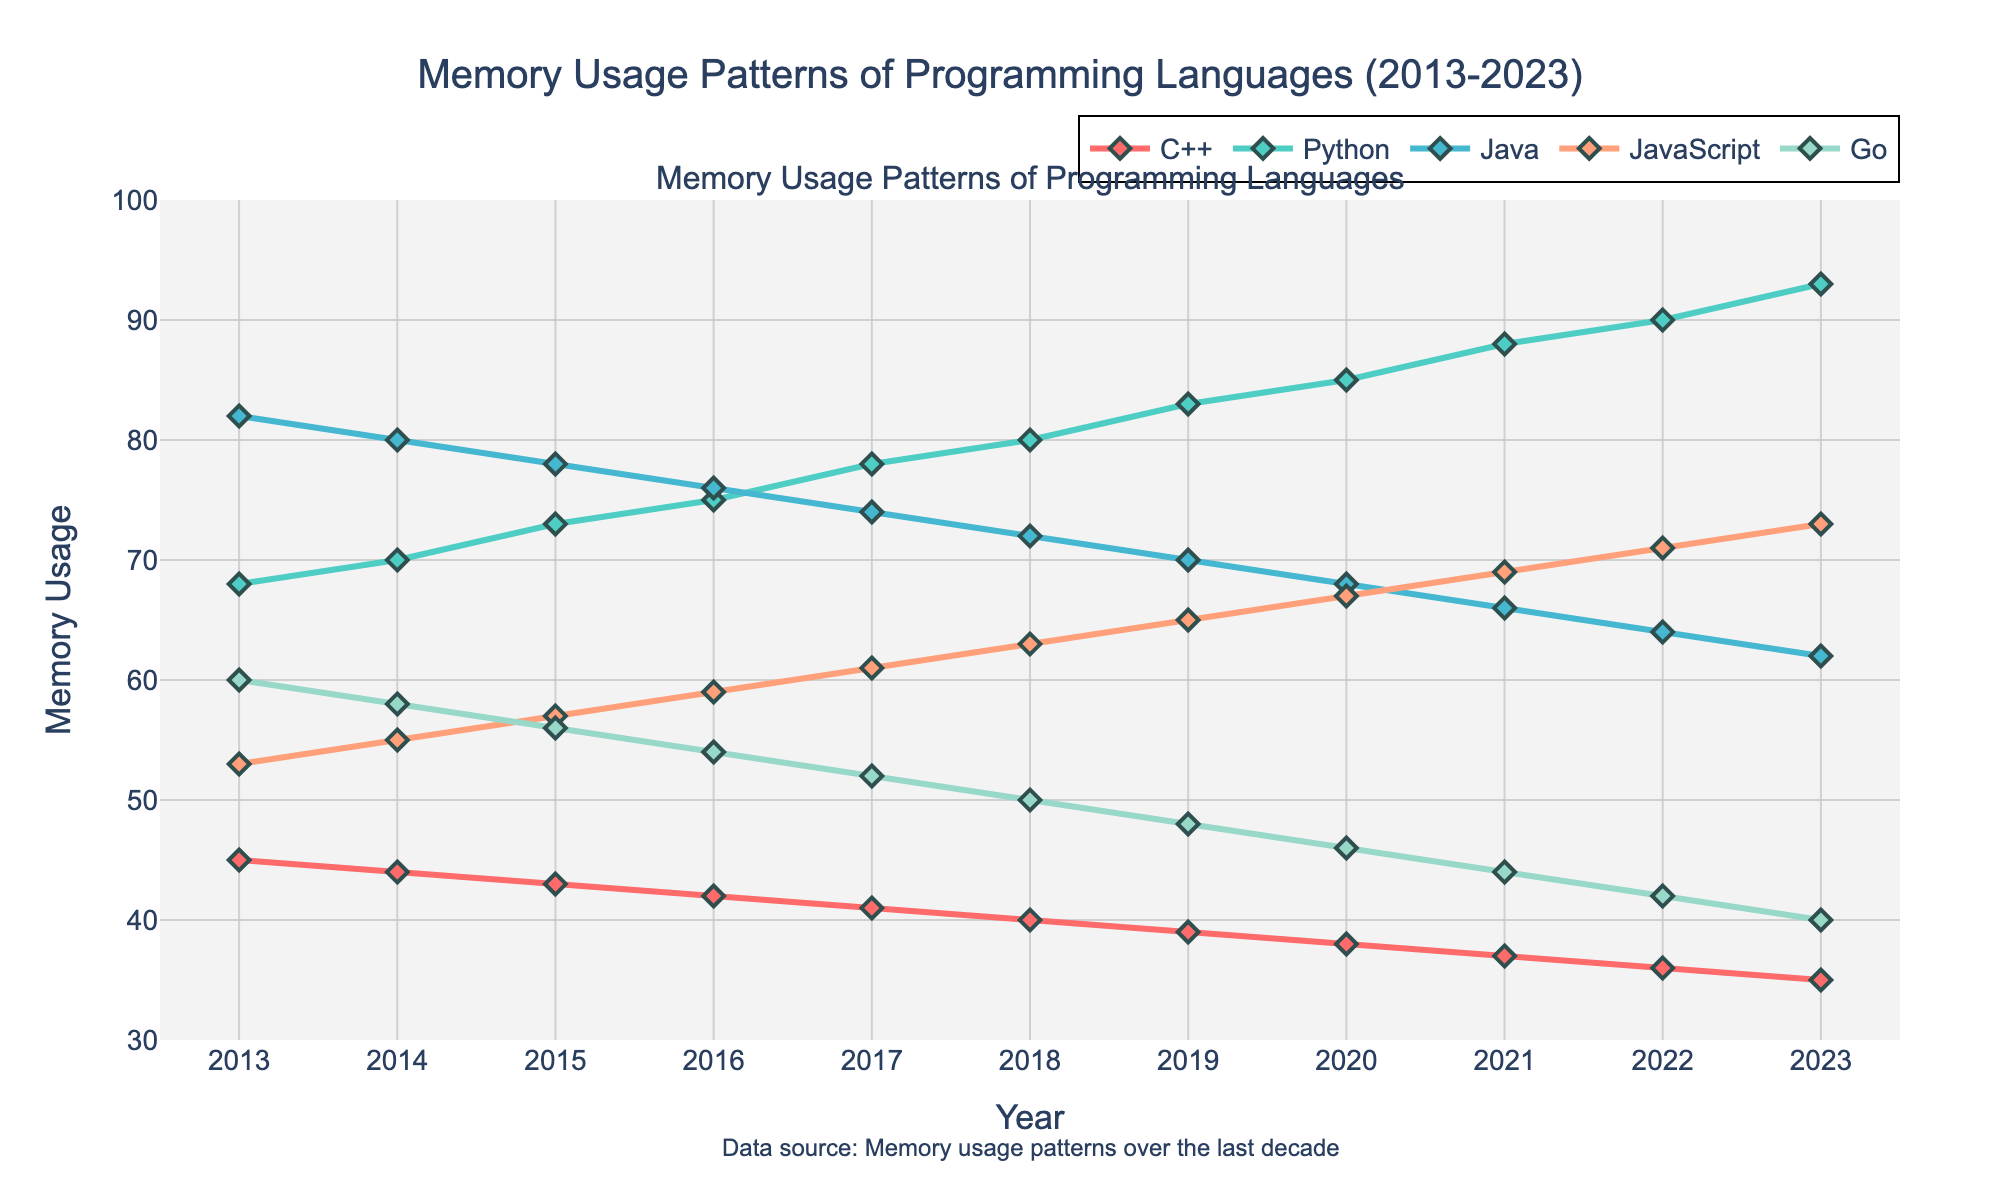What is the memory usage trend for Python from 2013 to 2023? Python's memory usage increases steadily every year from 68 in 2013 to 93 in 2023.
Answer: Increasing In which year did JavaScript surpass Java in memory usage? JavaScript surpasses Java in memory usage in 2021 when JavaScript's memory usage is 69, and Java's is 66.
Answer: 2021 Which language had the least memory usage in 2023? In the year 2023, C++ has the lowest memory usage of all the programming languages at 35.
Answer: C++ What is the average memory usage of Go between 2013 and 2023? The average can be calculated by summing up the values for Go from 2013 to 2023 and dividing by the number of years. (60+58+56+54+52+50+48+46+44+42+40)/11 = 50.
Answer: 50 Between which two consecutive years did Python's memory usage increase the most? The biggest increase for Python is between 2021 and 2022, with an increase from 88 to 90, a difference of 2.
Answer: 2021-2022 How many times does C++ have a memory usage below 40 between 2013 and 2023? C++ dips below 40 in 2019 (39), 2020 (38), 2021 (37), 2022 (36), and 2023 (35).
Answer: 5 What is the range of memory usage values for Java from 2013 to 2023? The range is calculated by subtracting the smallest memory usage from the largest memory usage for Java. 82 (2013) - 62 (2023) = 20.
Answer: 20 Did any language have a constant memory usage trend, neither increasing nor decreasing? No language shows a constant trend throughout the decade; all have either increasing or decreasing trends.
Answer: No 